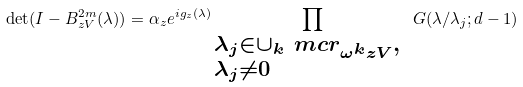<formula> <loc_0><loc_0><loc_500><loc_500>\det ( I - B ^ { 2 m } _ { z V } ( \lambda ) ) = \alpha _ { z } e ^ { i g _ { z } ( \lambda ) } \prod _ { \begin{subarray} { c } \lambda _ { j } \in \cup _ { k } \ m c r _ { \omega ^ { k } z V } , \ \\ \lambda _ { j } \not = 0 \end{subarray} } G ( \lambda / \lambda _ { j } ; d - 1 )</formula> 